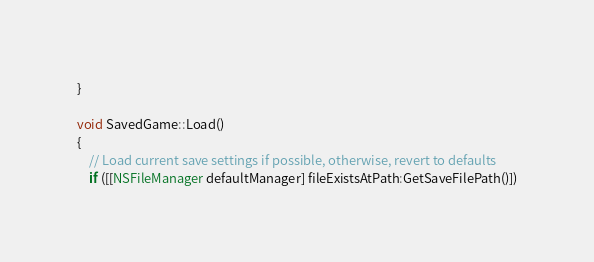Convert code to text. <code><loc_0><loc_0><loc_500><loc_500><_ObjectiveC_>}

void SavedGame::Load()
{
	// Load current save settings if possible, otherwise, revert to defaults
	if ([[NSFileManager defaultManager] fileExistsAtPath:GetSaveFilePath()])</code> 